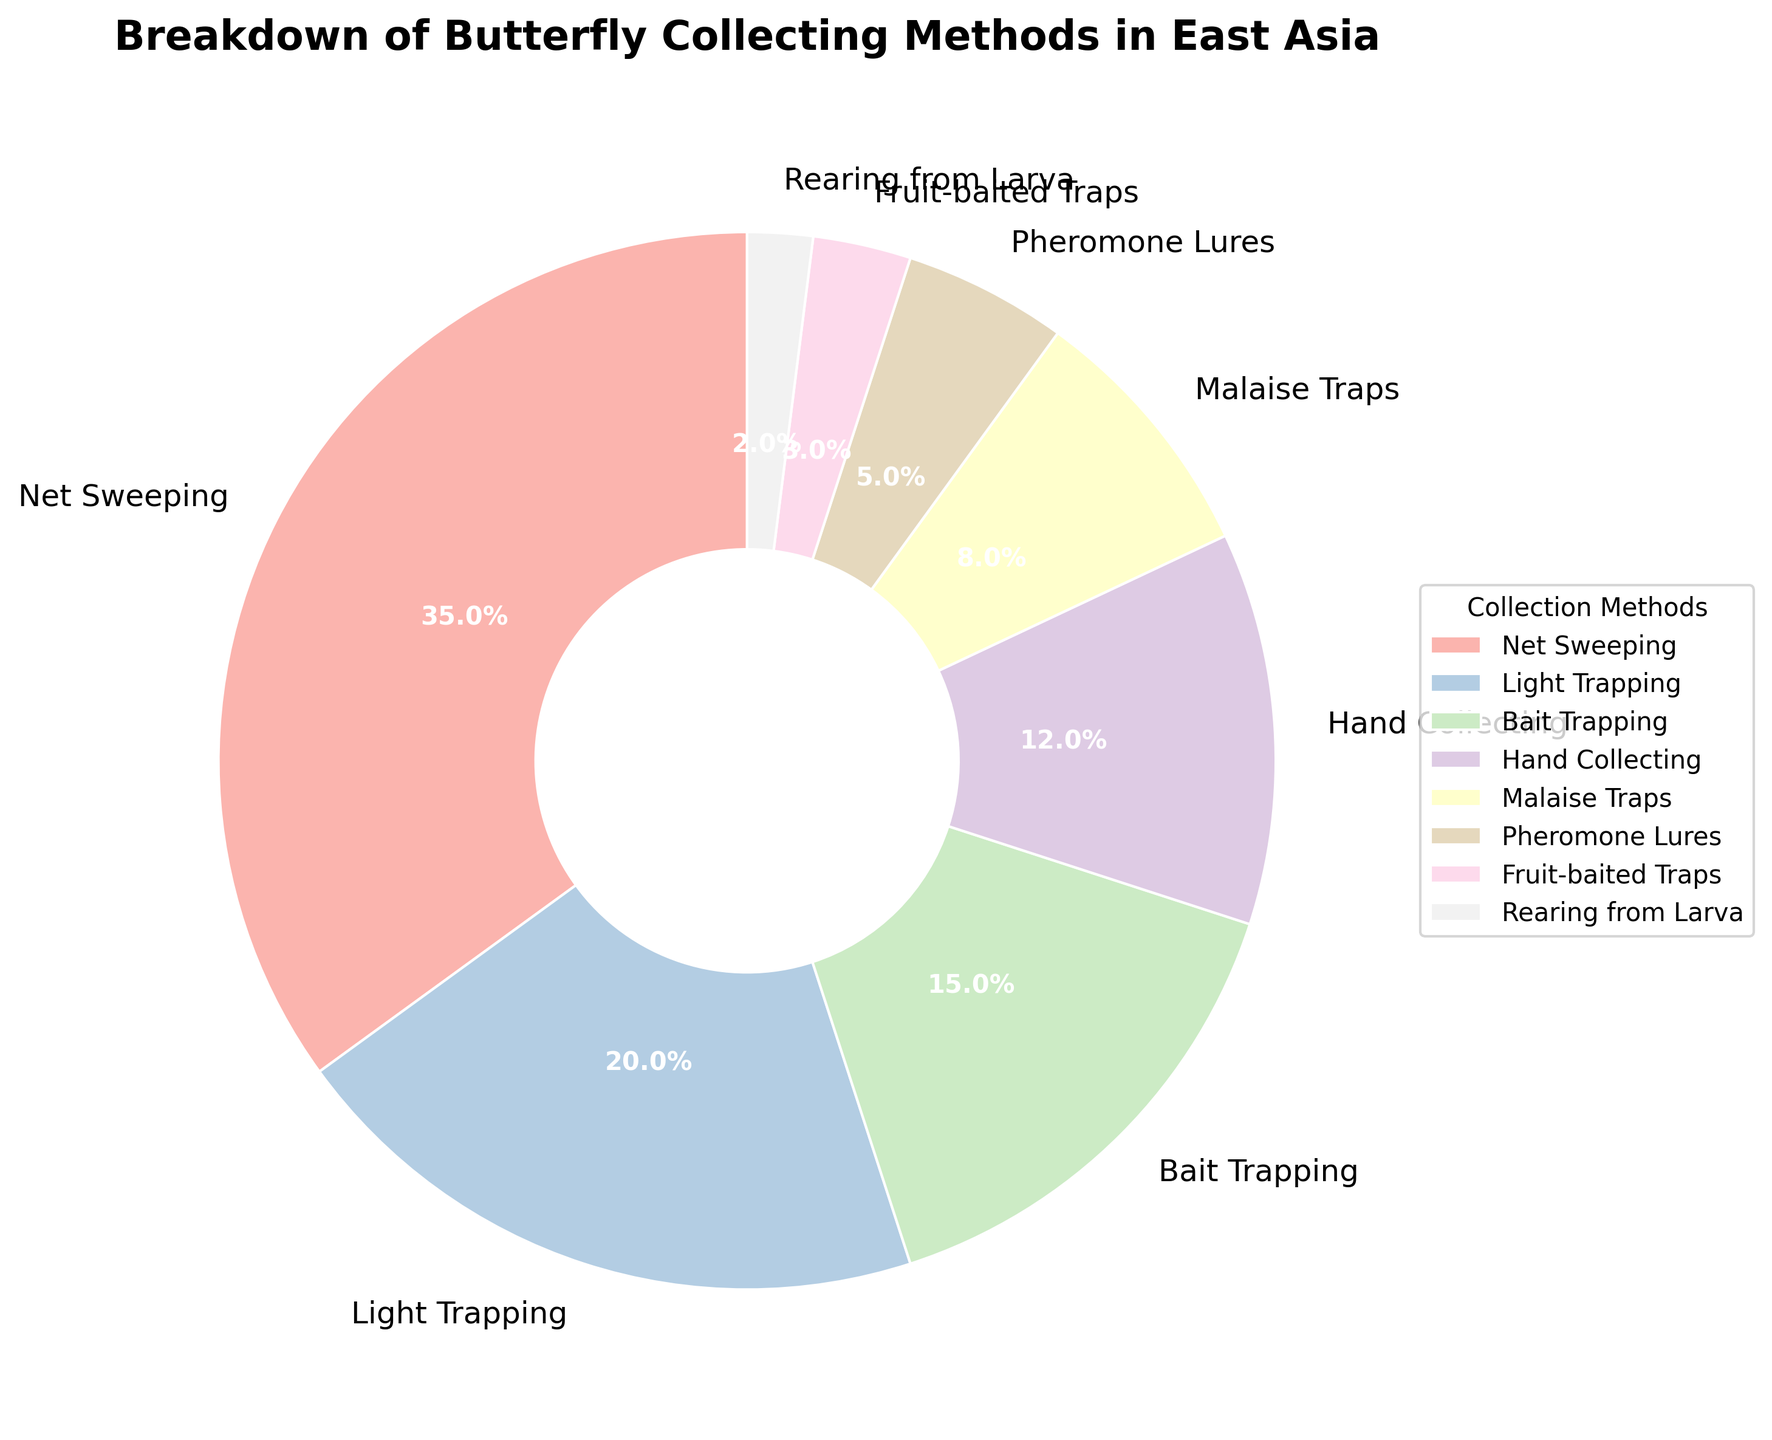What's the most common butterfly collecting method in East Asia? The pie chart shows the percentages of different collecting methods, with Net Sweeping having the largest segment at 35%.
Answer: Net Sweeping Which method is more commonly used, Bait Trapping or Hand Collecting? According to the chart, Bait Trapping accounts for 15% while Hand Collecting accounts for 12%.
Answer: Bait Trapping What is the total percentage of the top 3 collecting methods? The top 3 methods are Net Sweeping (35%), Light Trapping (20%), and Bait Trapping (15%). Adding them gives 35 + 20 + 15 = 70%.
Answer: 70% Is the use of Light Trapping greater than the combined use of Malaise Traps and Pheromone Lures? Light Trapping is used 20% of the time. Malaise Traps and Pheromone Lures combined are 8% + 5% = 13%. Therefore, 20% is greater than 13%.
Answer: Yes How does the use of Hand Collecting compare to Fruit-baited Traps? Hand Collecting is used 12% of the time while Fruit-baited Traps are used 3%. Thus, Hand Collecting is more common.
Answer: Hand Collecting is more common Which three methods have the smallest usage percentages? The chart shows Rearing from Larva (2%), Fruit-baited Traps (3%), and Pheromone Lures (5%) as the least common methods.
Answer: Rearing from Larva, Fruit-baited Traps, Pheromone Lures What percentage more is Net Sweeping used compared to Light Trapping? Net Sweeping is used 35% of the time, Light Trapping 20%. The difference is 35 - 20 = 15%.
Answer: 15% If you were to group all trapping methods together (Light Trapping, Bait Trapping, Malaise Traps, Fruit-baited Traps, and Pheromone Lures), what would be their combined percentage? Adding up their percentages: 20% (Light Trapping) + 15% (Bait Trapping) + 8% (Malaise Traps) + 3% (Fruit-baited Traps) + 5% (Pheromone Lures) = 51%.
Answer: 51% Which method appears to be twice as common as another listed method? Light Trapping (20%) appears to be roughly twice as common as Bait Trapping (15%) if we approximate, but exact comparisons show 20% is not exactly twice any value listed. However, Light Trapping is exactly twice as common as Pheromone Lures (5%).
Answer: Light Trapping is twice as common as Pheromone Lures How many methods have a usage percentage greater than 10%? By inspecting the chart, the methods above 10% are Net Sweeping (35%), Light Trapping (20%), Bait Trapping (15%), and Hand Collecting (12%). In total, 4 methods are above 10%.
Answer: 4 